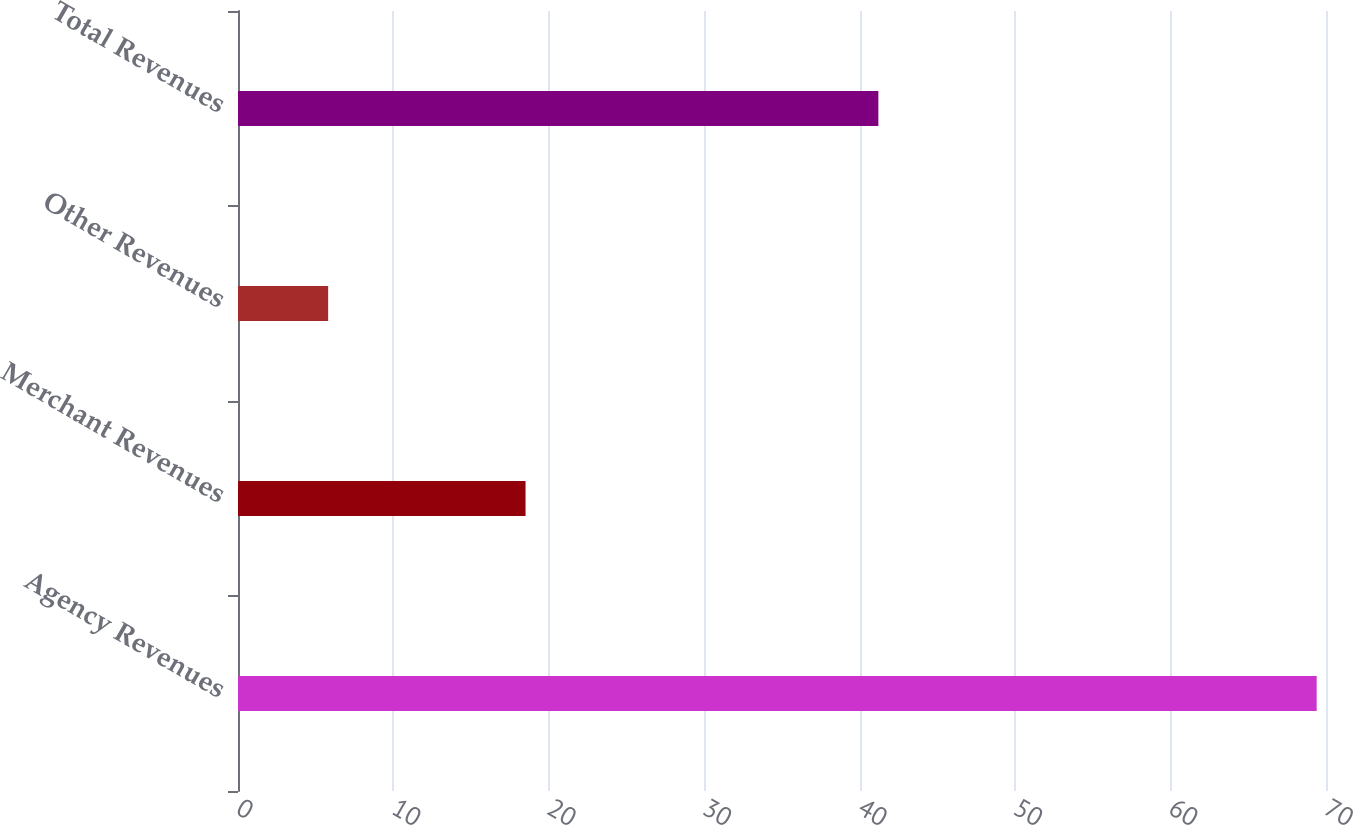Convert chart. <chart><loc_0><loc_0><loc_500><loc_500><bar_chart><fcel>Agency Revenues<fcel>Merchant Revenues<fcel>Other Revenues<fcel>Total Revenues<nl><fcel>69.4<fcel>18.5<fcel>5.8<fcel>41.2<nl></chart> 